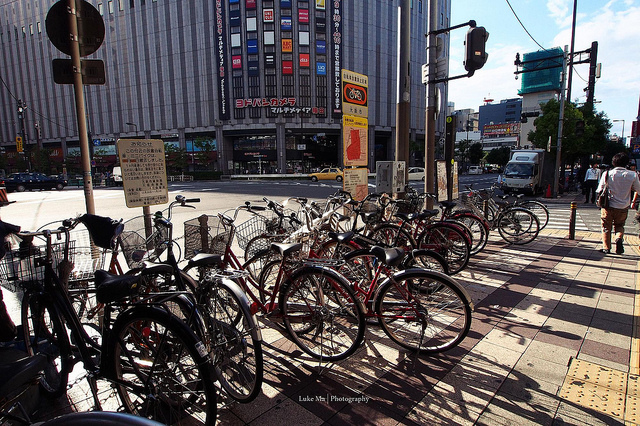Read all the text in this image. Photography 